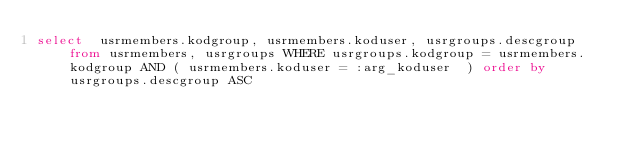Convert code to text. <code><loc_0><loc_0><loc_500><loc_500><_SQL_>select  usrmembers.kodgroup, usrmembers.koduser, usrgroups.descgroup from usrmembers, usrgroups WHERE usrgroups.kodgroup = usrmembers.kodgroup AND ( usrmembers.koduser = :arg_koduser  ) order by usrgroups.descgroup ASC</code> 